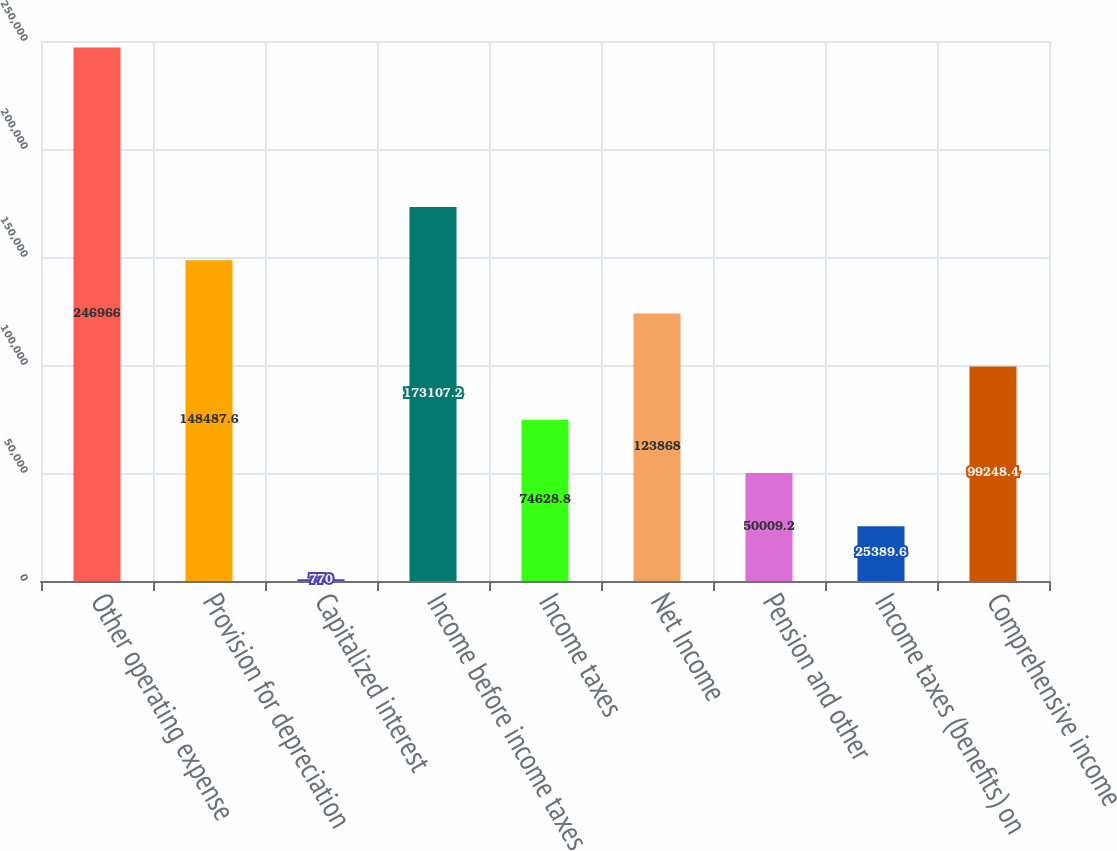Convert chart. <chart><loc_0><loc_0><loc_500><loc_500><bar_chart><fcel>Other operating expense<fcel>Provision for depreciation<fcel>Capitalized interest<fcel>Income before income taxes<fcel>Income taxes<fcel>Net Income<fcel>Pension and other<fcel>Income taxes (benefits) on<fcel>Comprehensive income<nl><fcel>246966<fcel>148488<fcel>770<fcel>173107<fcel>74628.8<fcel>123868<fcel>50009.2<fcel>25389.6<fcel>99248.4<nl></chart> 